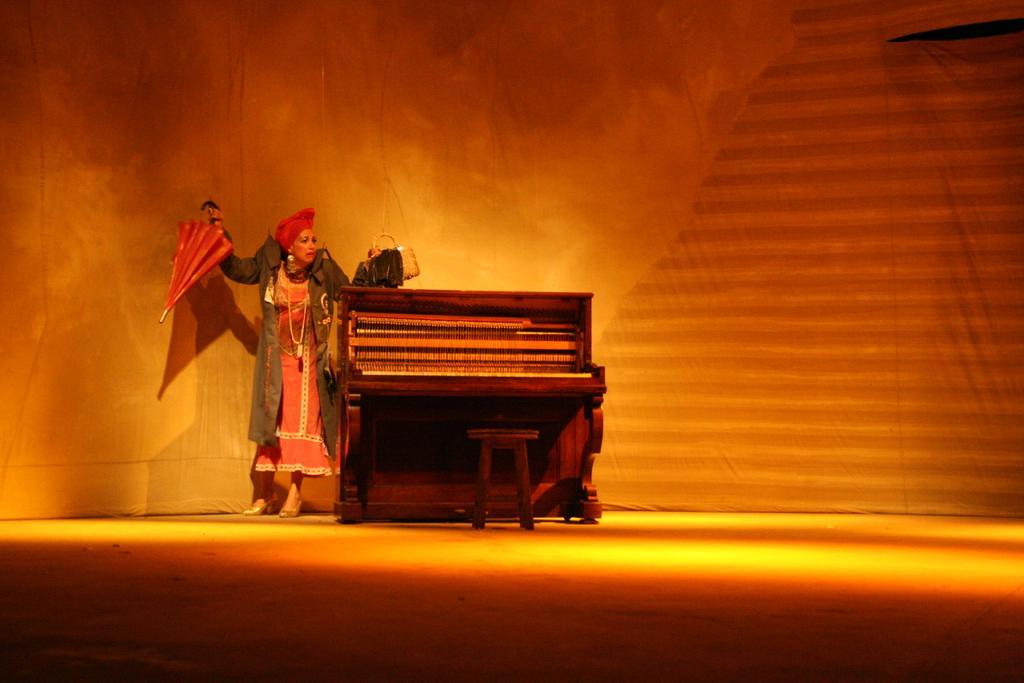Please provide a concise description of this image. In the middle there is a piano. On the left there is a woman she is wearing black jacket ,she is holding umbrella and hand bag. I think this is a stage performance. 